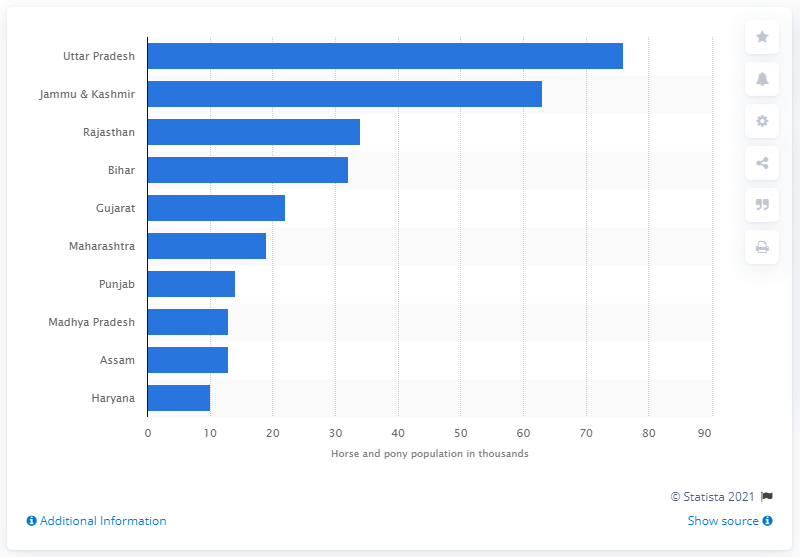List a handful of essential elements in this visual. Uttar Pradesh had the highest horse and pony population in India in 2019, according to the latest statistics. 